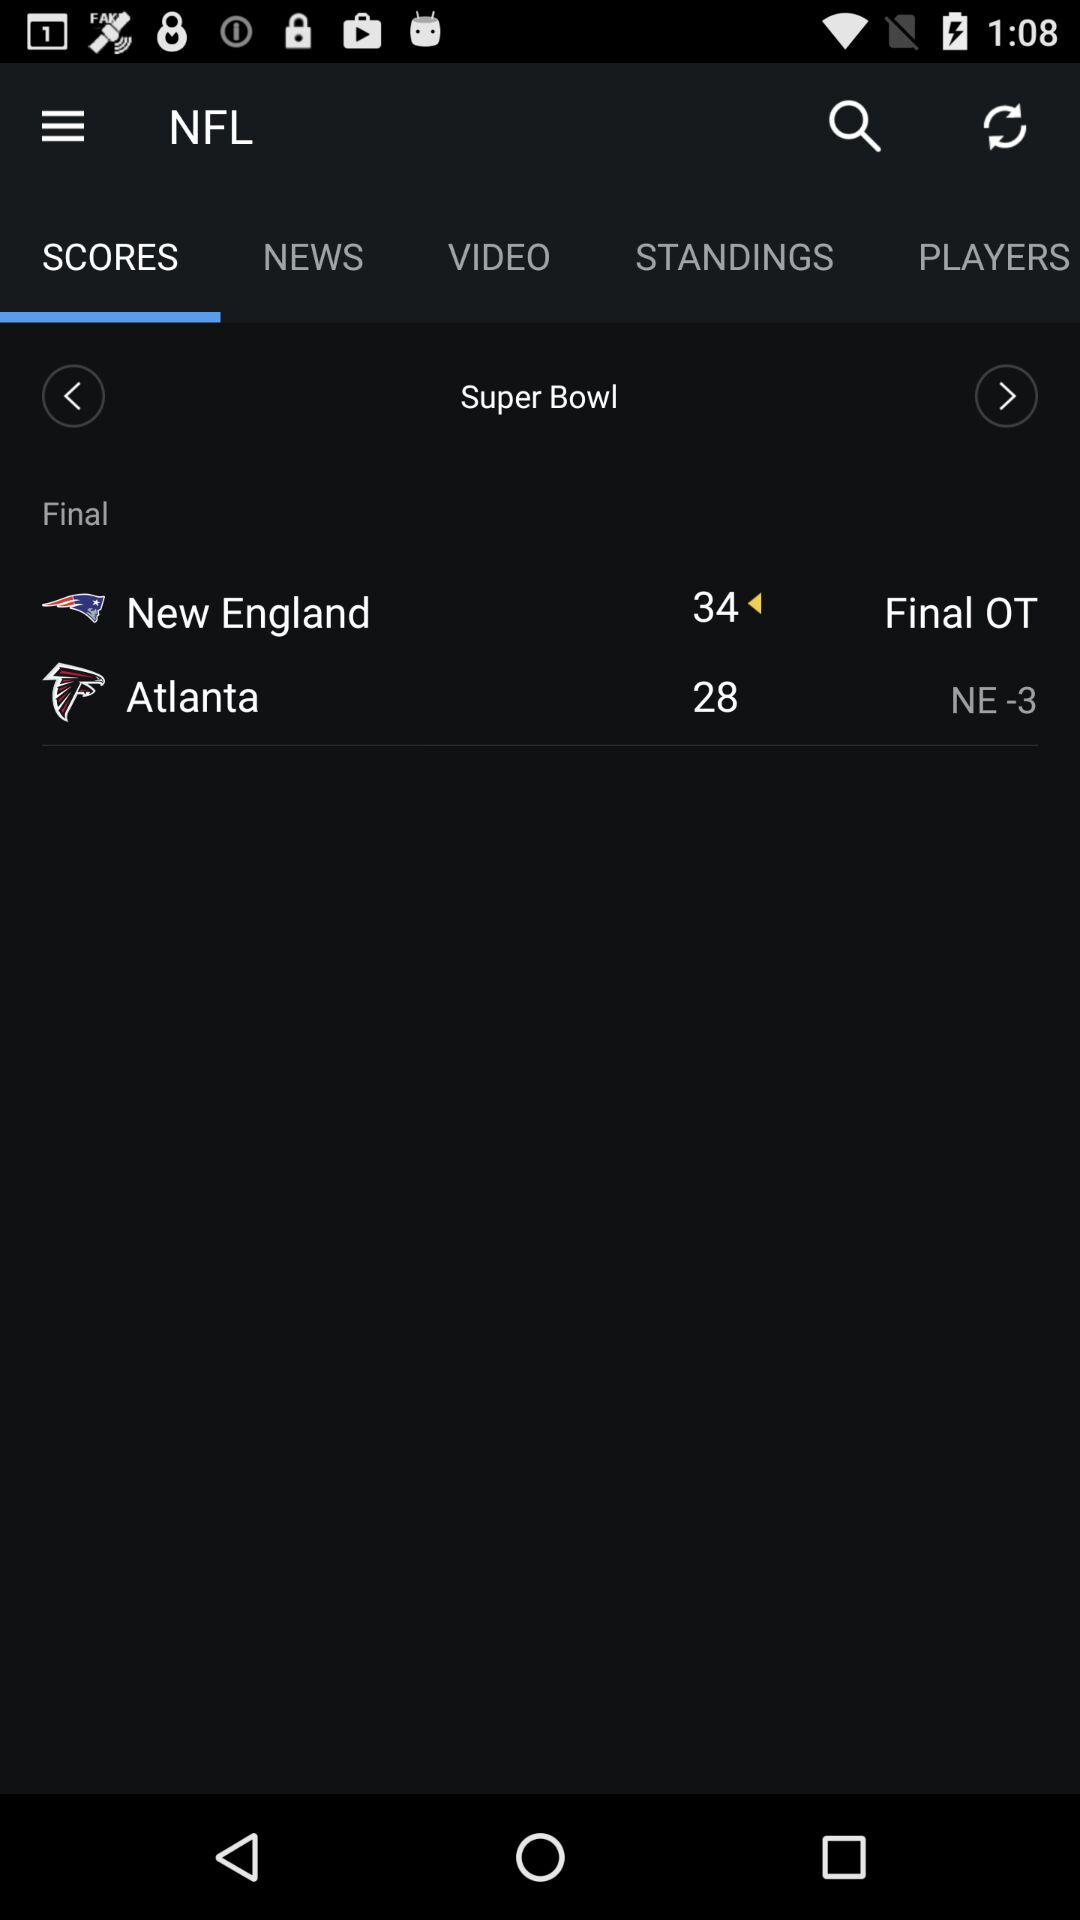How many points did New England win by?
Answer the question using a single word or phrase. 6 